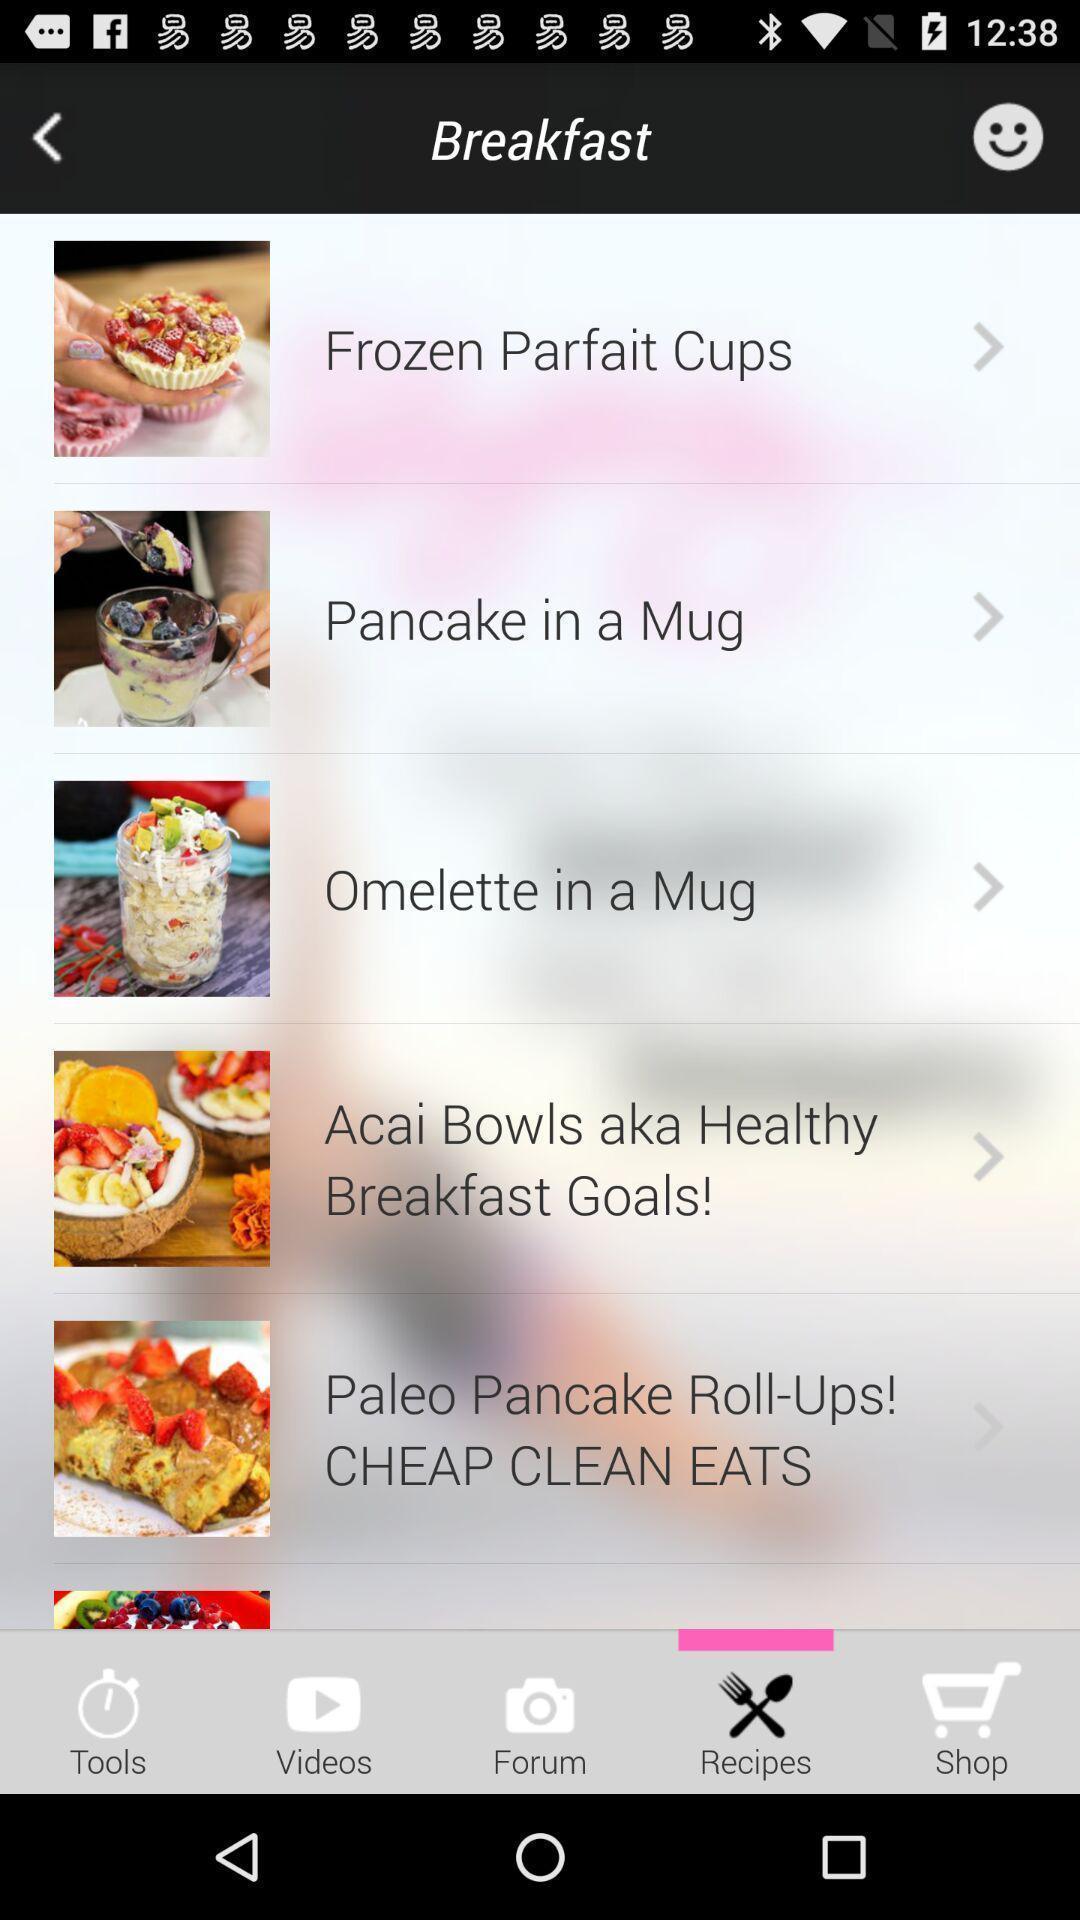What is the overall content of this screenshot? Page displaying the list of breakfast recipes. 